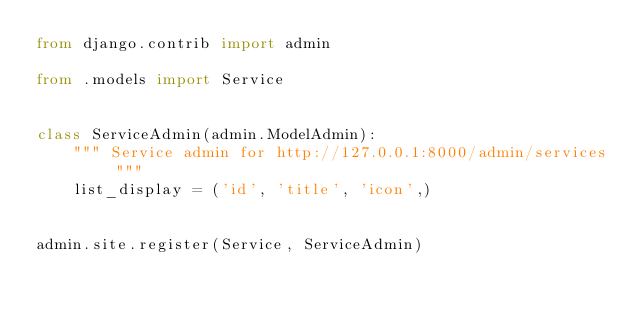Convert code to text. <code><loc_0><loc_0><loc_500><loc_500><_Python_>from django.contrib import admin

from .models import Service


class ServiceAdmin(admin.ModelAdmin):
    """ Service admin for http://127.0.0.1:8000/admin/services """
    list_display = ('id', 'title', 'icon',)


admin.site.register(Service, ServiceAdmin)
</code> 